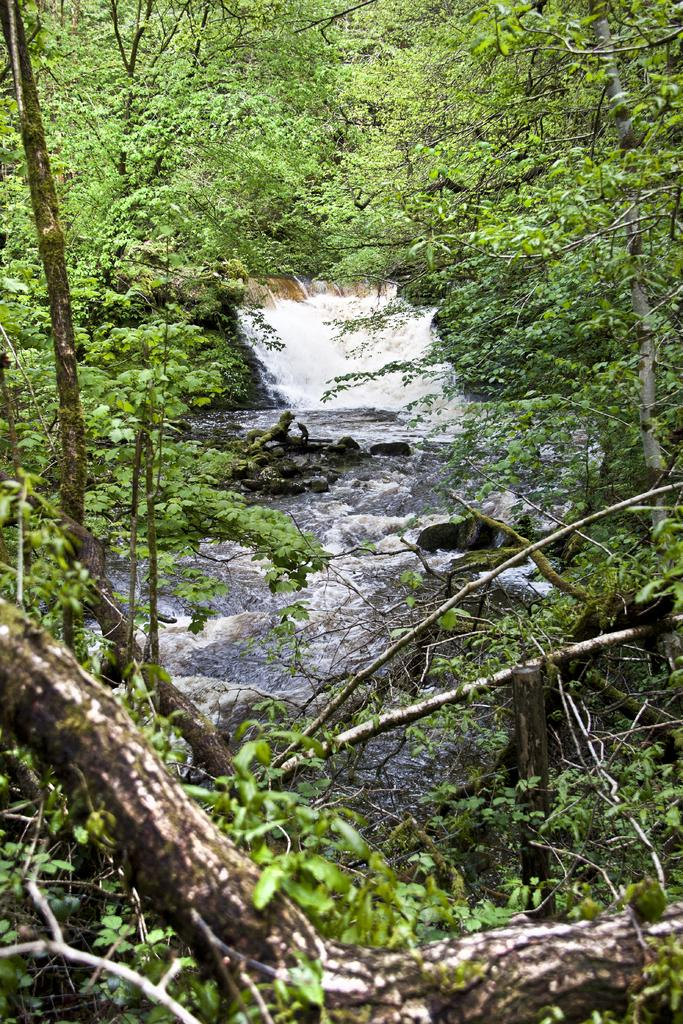What is visible in the image? Water, rocks, and trees are visible in the image. Can you describe the water in the image? The water is visible in the image. What other natural elements can be seen in the image? Rocks and trees are also visible in the image. What type of honey can be seen dripping from the trees in the image? There is no honey present in the image; it features water, rocks, and trees. What kind of operation is being performed on the ear in the image? There is no ear or operation present in the image. 